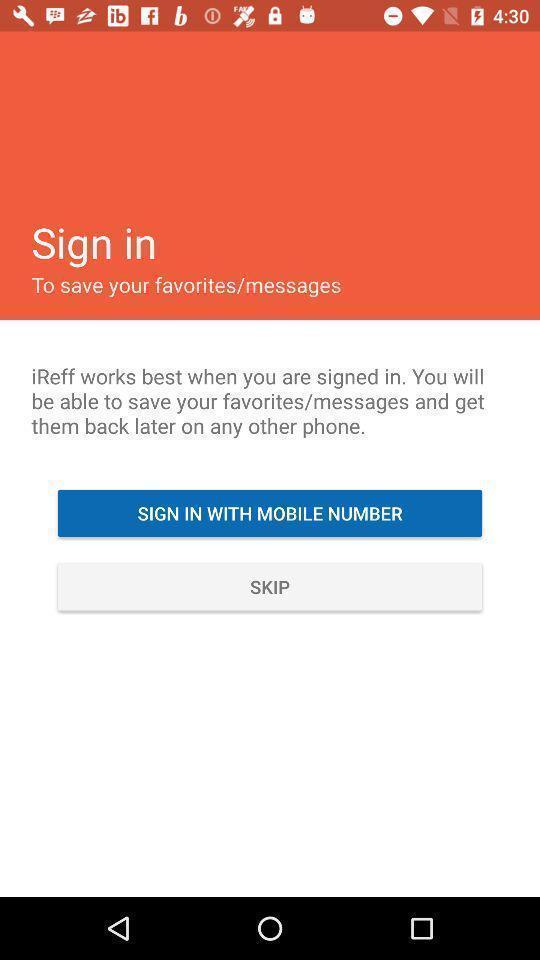Describe the key features of this screenshot. Sign-in page of a social app. 